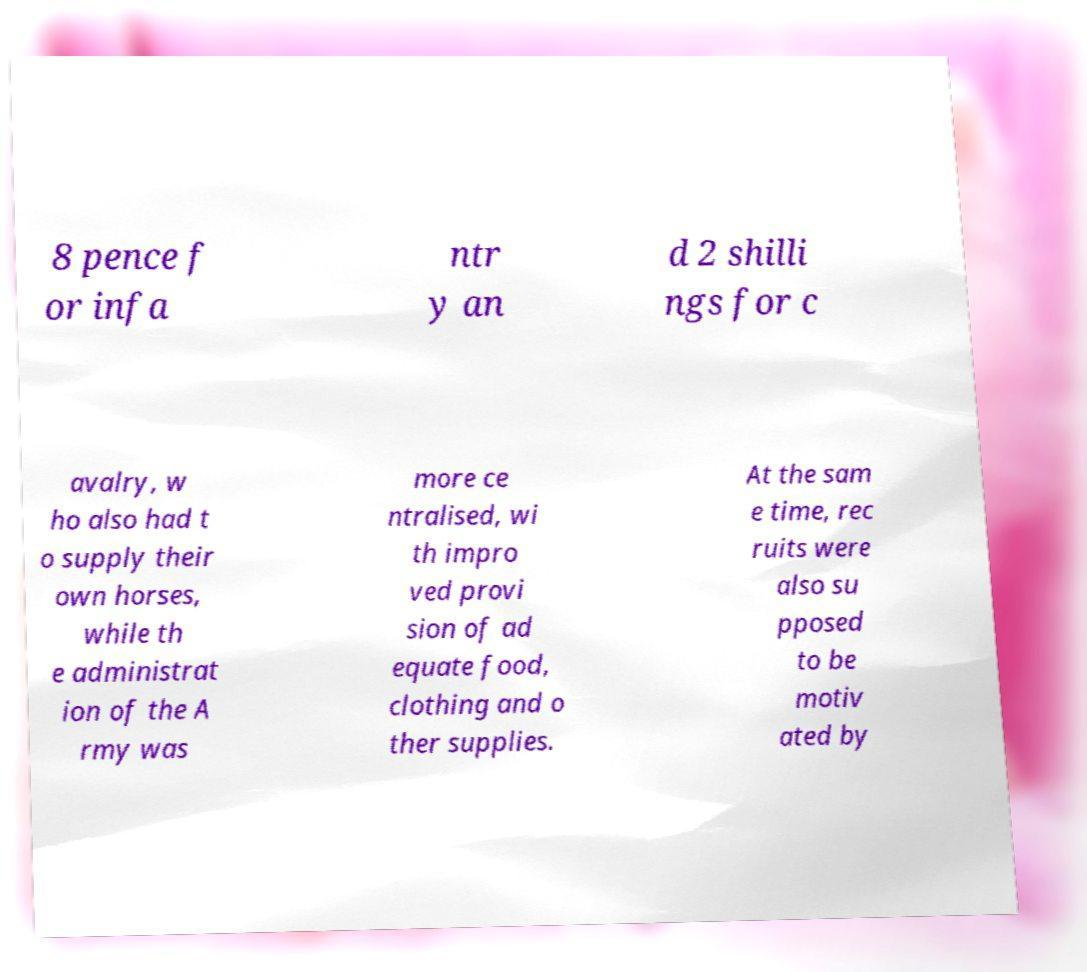There's text embedded in this image that I need extracted. Can you transcribe it verbatim? 8 pence f or infa ntr y an d 2 shilli ngs for c avalry, w ho also had t o supply their own horses, while th e administrat ion of the A rmy was more ce ntralised, wi th impro ved provi sion of ad equate food, clothing and o ther supplies. At the sam e time, rec ruits were also su pposed to be motiv ated by 